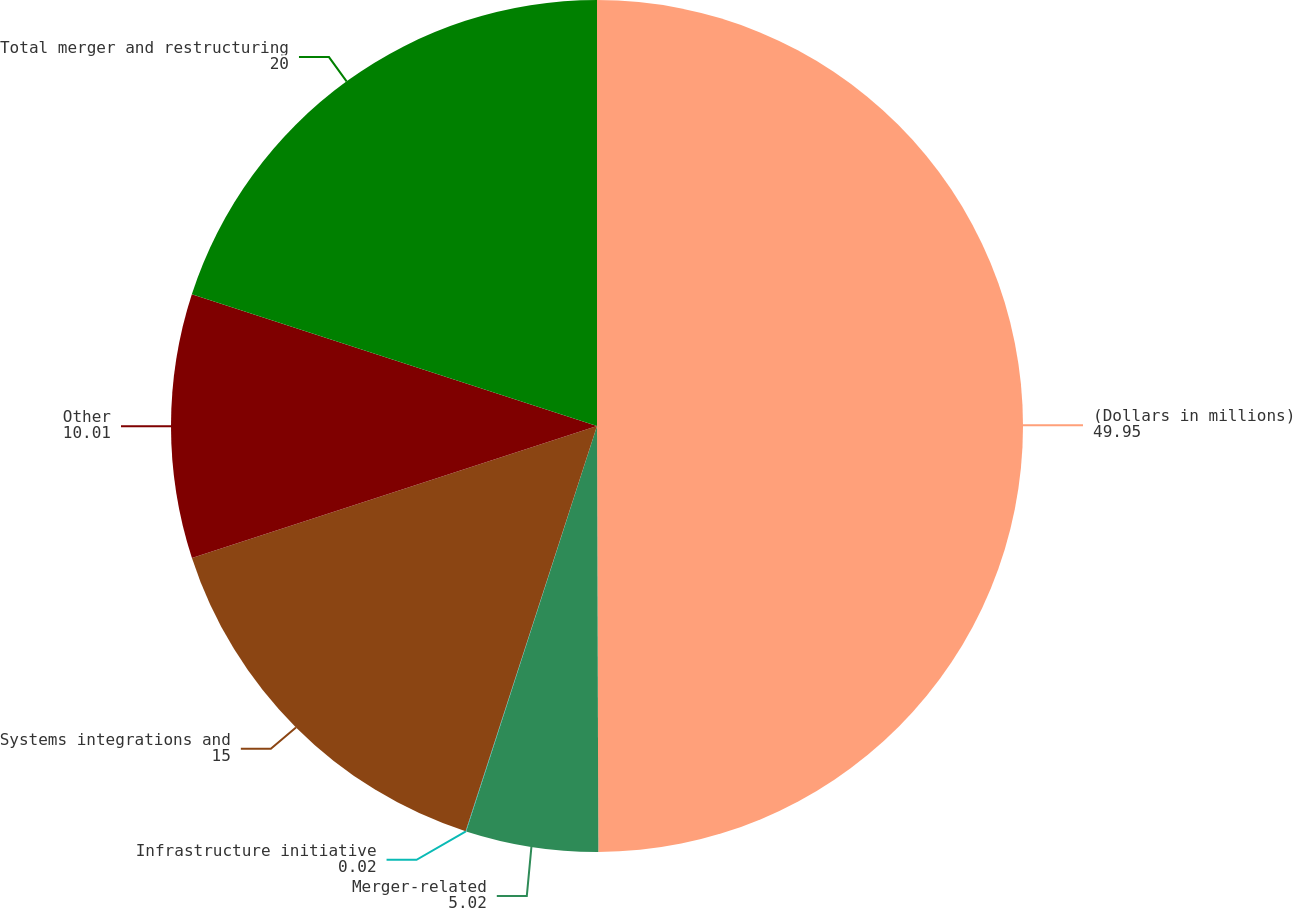Convert chart. <chart><loc_0><loc_0><loc_500><loc_500><pie_chart><fcel>(Dollars in millions)<fcel>Merger-related<fcel>Infrastructure initiative<fcel>Systems integrations and<fcel>Other<fcel>Total merger and restructuring<nl><fcel>49.95%<fcel>5.02%<fcel>0.02%<fcel>15.0%<fcel>10.01%<fcel>20.0%<nl></chart> 